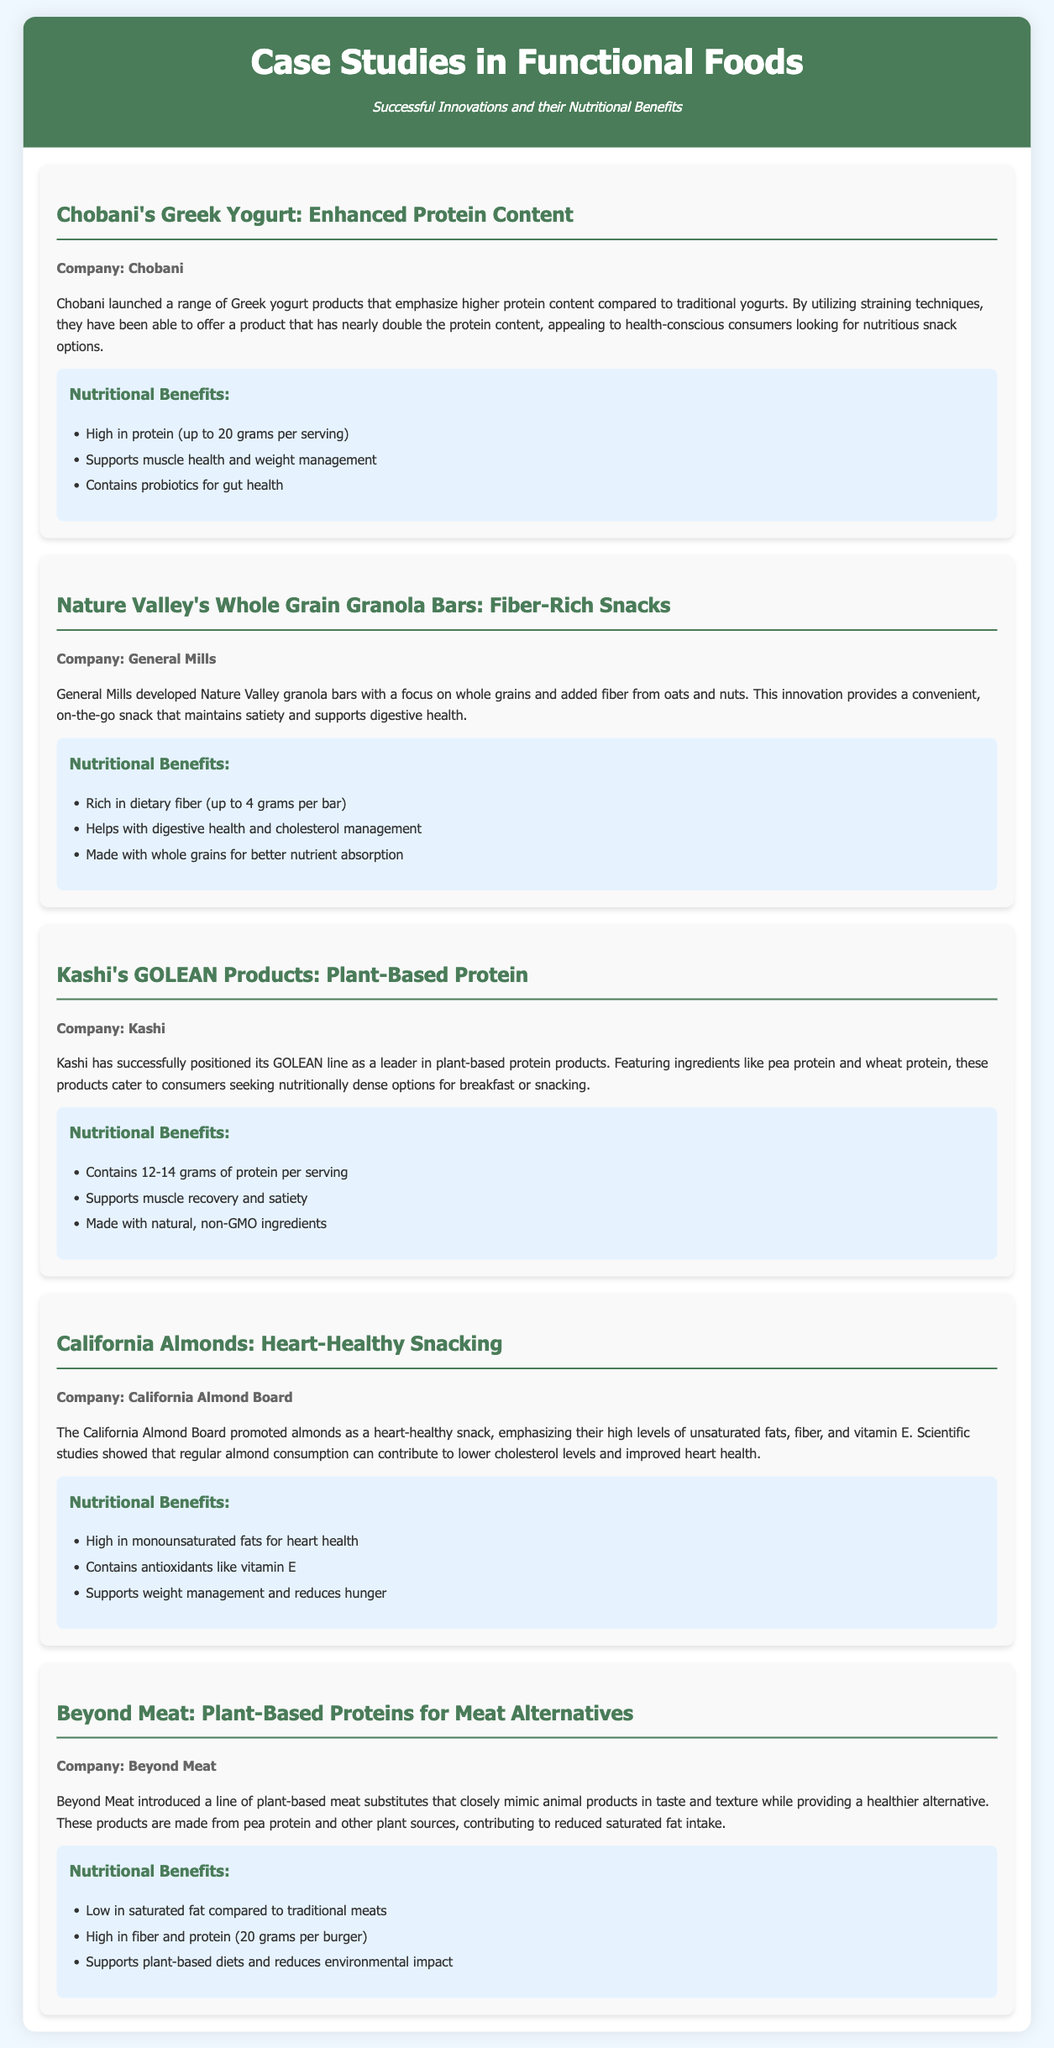What is the protein content in Chobani's Greek Yogurt? The document states that Chobani's Greek yogurt contains up to 20 grams of protein per serving.
Answer: 20 grams What key nutrient do Nature Valley's granola bars provide? The document highlights that Nature Valley granola bars are rich in dietary fiber.
Answer: Dietary fiber Which company developed Kashi's GOLEAN products? The document mentions Kashi as the company behind the GOLEAN products.
Answer: Kashi What are the main ingredients in Beyond Meat products? The document indicates that Beyond Meat products are made from pea protein and other plant sources.
Answer: Pea protein and other plant sources How much protein do Kashi's GOLEAN products contain per serving? According to the document, Kashi's GOLEAN products contain 12-14 grams of protein per serving.
Answer: 12-14 grams What health benefit is associated with regular almond consumption? The document notes that regular almond consumption can contribute to lower cholesterol levels.
Answer: Lower cholesterol levels What nutritional advantage does Chobani's Greek Yogurt claim? The document emphasizes that it supports muscle health and weight management.
Answer: Supports muscle health and weight management Which type of fat is high in California Almonds? The document specifies that California Almonds are high in monounsaturated fats.
Answer: Monounsaturated fats How does Beyond Meat benefit dietary choices? The document explains that Beyond Meat supports plant-based diets and reduces environmental impact.
Answer: Supports plant-based diets 